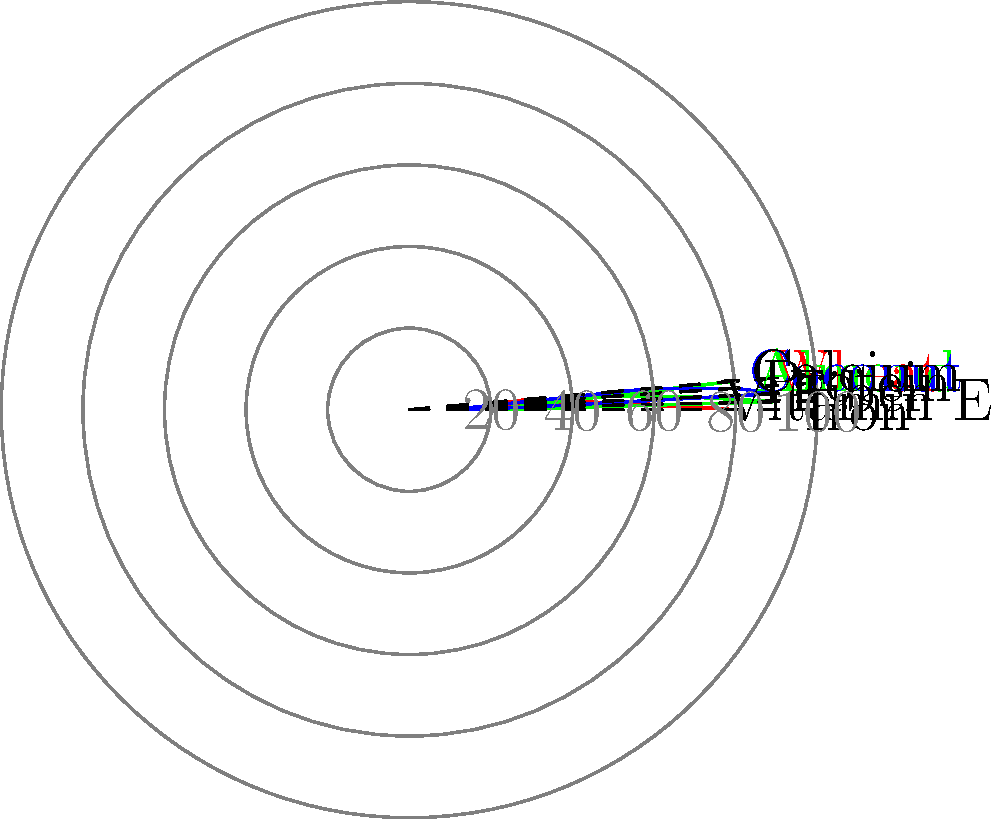Analyze the radar chart depicting the micronutrient composition of wheat, almond, and coconut flours. Which flour would you recommend to a client seeking to increase their dietary fiber intake while maintaining a moderate protein content? To answer this question, we need to examine the radar chart and compare the fiber and protein content of each flour:

1. Wheat flour:
   - Fiber: Approximately 40% of the maximum value
   - Protein: Approximately 20% of the maximum value

2. Almond flour:
   - Fiber: Approximately 70% of the maximum value
   - Protein: Approximately 50% of the maximum value

3. Coconut flour:
   - Fiber: Approximately 90% of the maximum value
   - Protein: Approximately 80% of the maximum value

Comparing these values:

1. Coconut flour has the highest fiber content (90%) and a high protein content (80%).
2. Almond flour has the second-highest fiber content (70%) and a moderate protein content (50%).
3. Wheat flour has the lowest fiber content (40%) and the lowest protein content (20%).

The client is seeking to increase dietary fiber intake while maintaining moderate protein content. Based on this criteria:

- Coconut flour offers the highest fiber content but may provide more protein than desired for a "moderate" intake.
- Almond flour provides a good balance of high fiber content and moderate protein content.
- Wheat flour is not suitable as it has the lowest fiber and protein content among the three options.

Therefore, almond flour would be the best recommendation for this client, as it offers a significant increase in dietary fiber while maintaining a moderate protein content.
Answer: Almond flour 